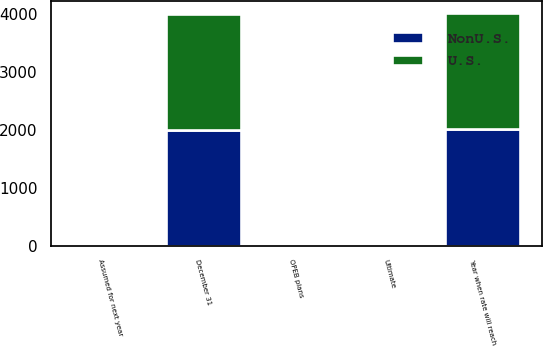<chart> <loc_0><loc_0><loc_500><loc_500><stacked_bar_chart><ecel><fcel>December 31<fcel>OPEB plans<fcel>Assumed for next year<fcel>Ultimate<fcel>Year when rate will reach<nl><fcel>U.S.<fcel>2007<fcel>6.6<fcel>9.25<fcel>5<fcel>2014<nl><fcel>NonU.S.<fcel>2007<fcel>5.8<fcel>5.75<fcel>4<fcel>2010<nl></chart> 